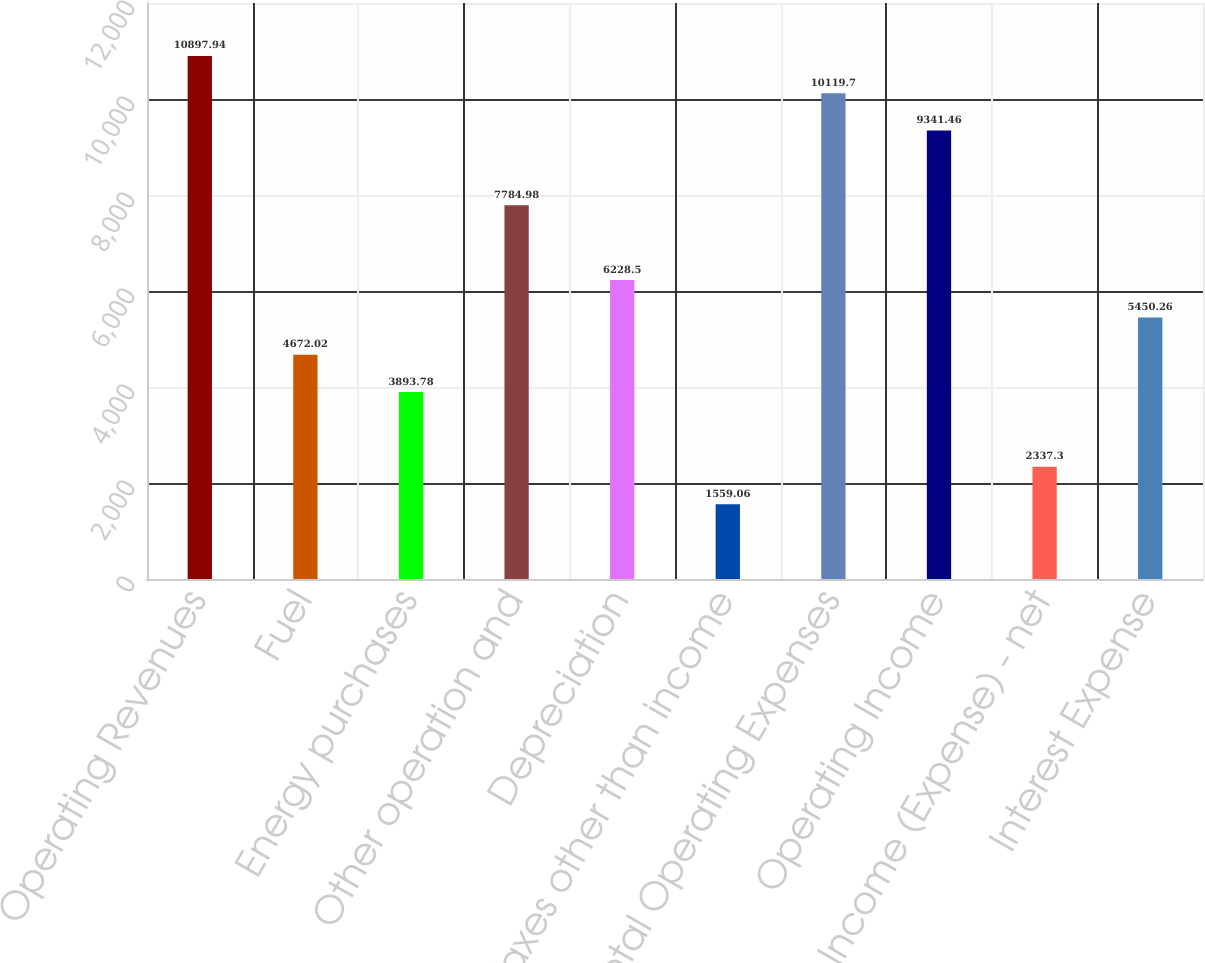Convert chart. <chart><loc_0><loc_0><loc_500><loc_500><bar_chart><fcel>Operating Revenues<fcel>Fuel<fcel>Energy purchases<fcel>Other operation and<fcel>Depreciation<fcel>Taxes other than income<fcel>Total Operating Expenses<fcel>Operating Income<fcel>Other Income (Expense) - net<fcel>Interest Expense<nl><fcel>10897.9<fcel>4672.02<fcel>3893.78<fcel>7784.98<fcel>6228.5<fcel>1559.06<fcel>10119.7<fcel>9341.46<fcel>2337.3<fcel>5450.26<nl></chart> 